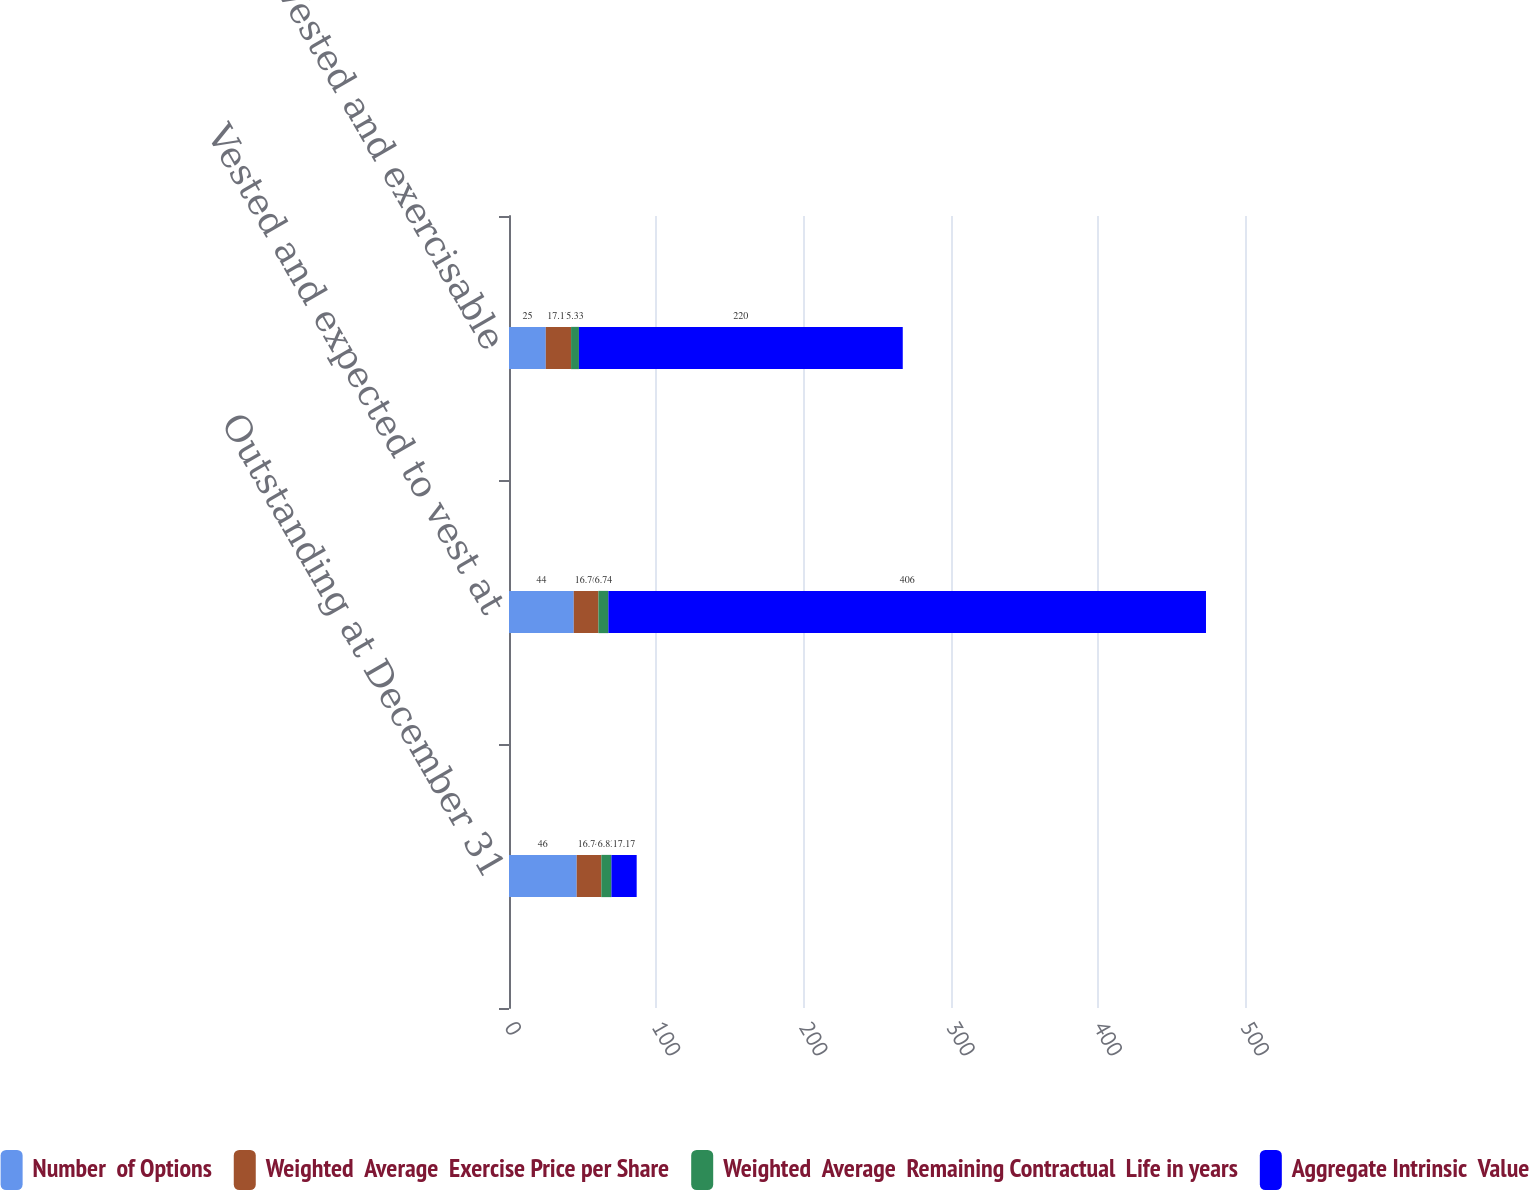Convert chart. <chart><loc_0><loc_0><loc_500><loc_500><stacked_bar_chart><ecel><fcel>Outstanding at December 31<fcel>Vested and expected to vest at<fcel>Vested and exercisable<nl><fcel>Number  of Options<fcel>46<fcel>44<fcel>25<nl><fcel>Weighted  Average  Exercise Price per Share<fcel>16.74<fcel>16.76<fcel>17.17<nl><fcel>Weighted  Average  Remaining Contractual  Life in years<fcel>6.83<fcel>6.74<fcel>5.33<nl><fcel>Aggregate Intrinsic  Value<fcel>17.17<fcel>406<fcel>220<nl></chart> 